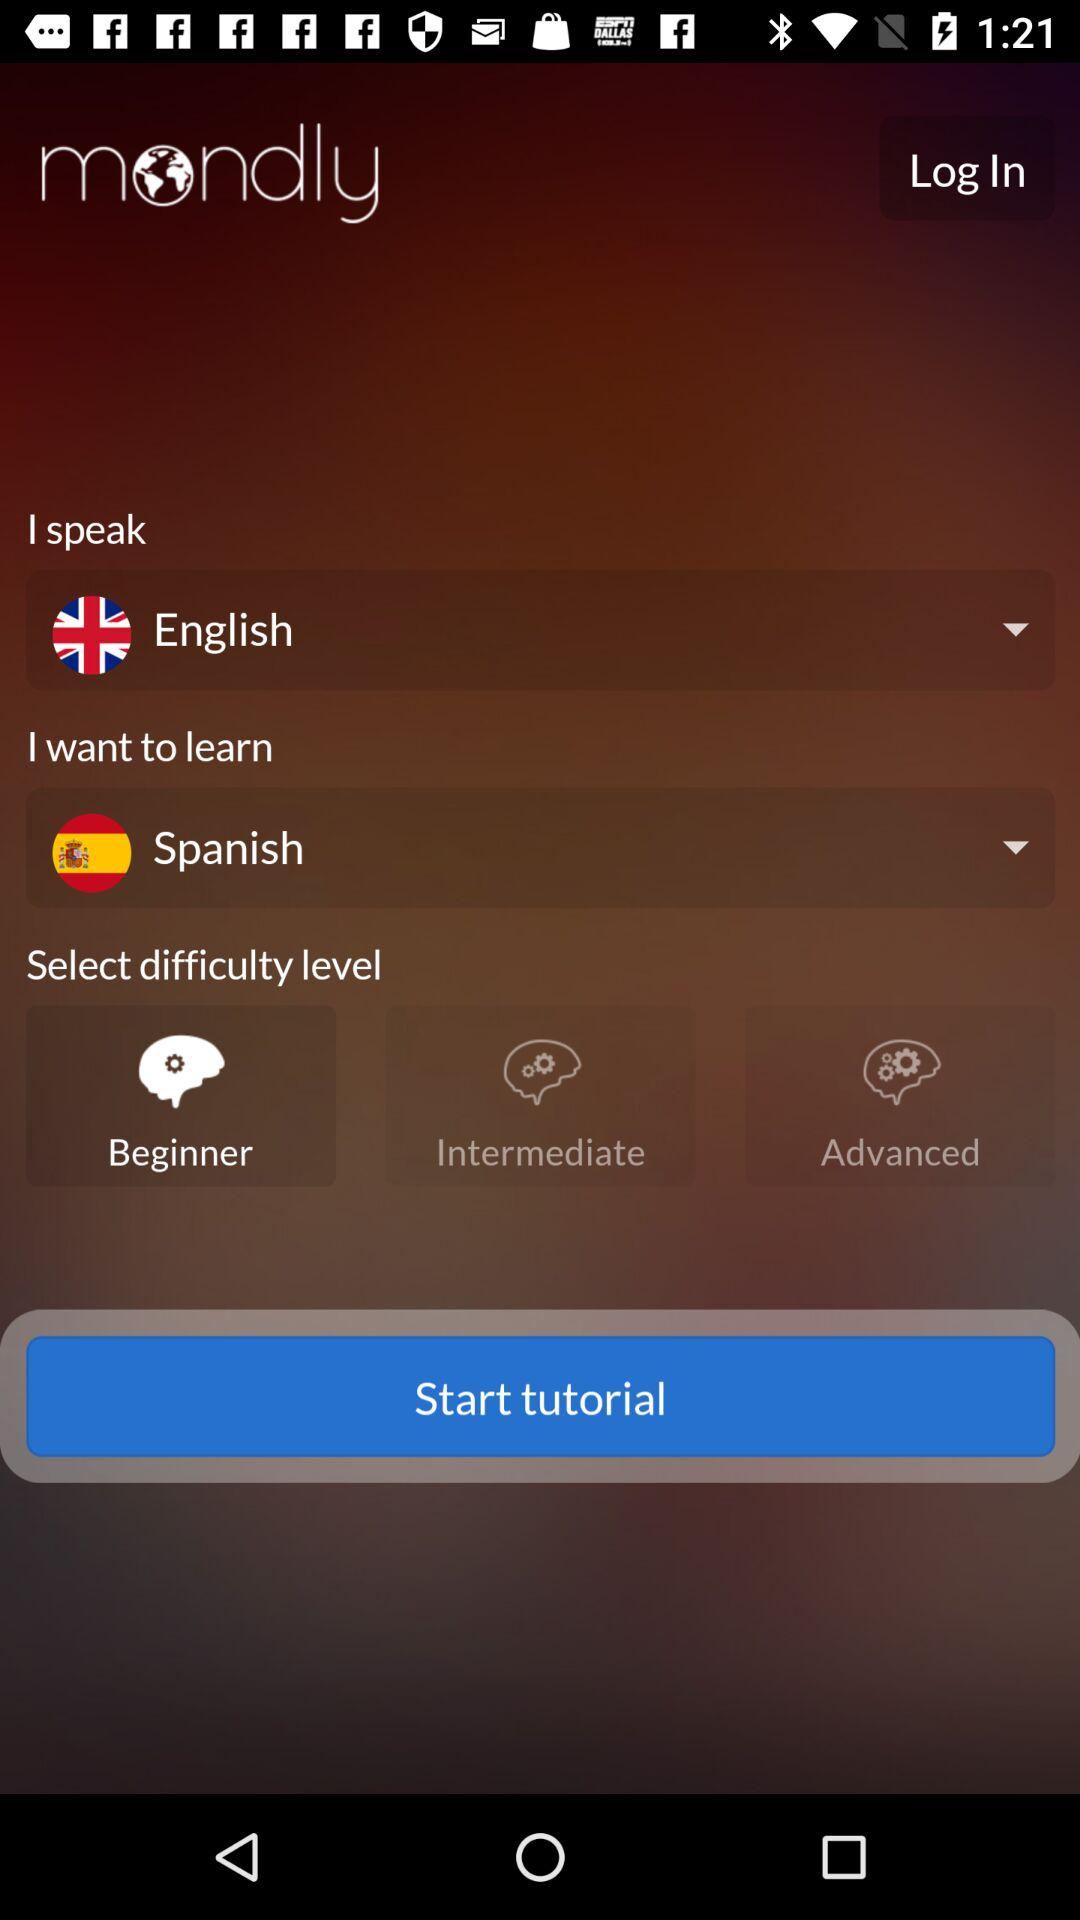How many levels of difficulty are there?
Answer the question using a single word or phrase. 3 